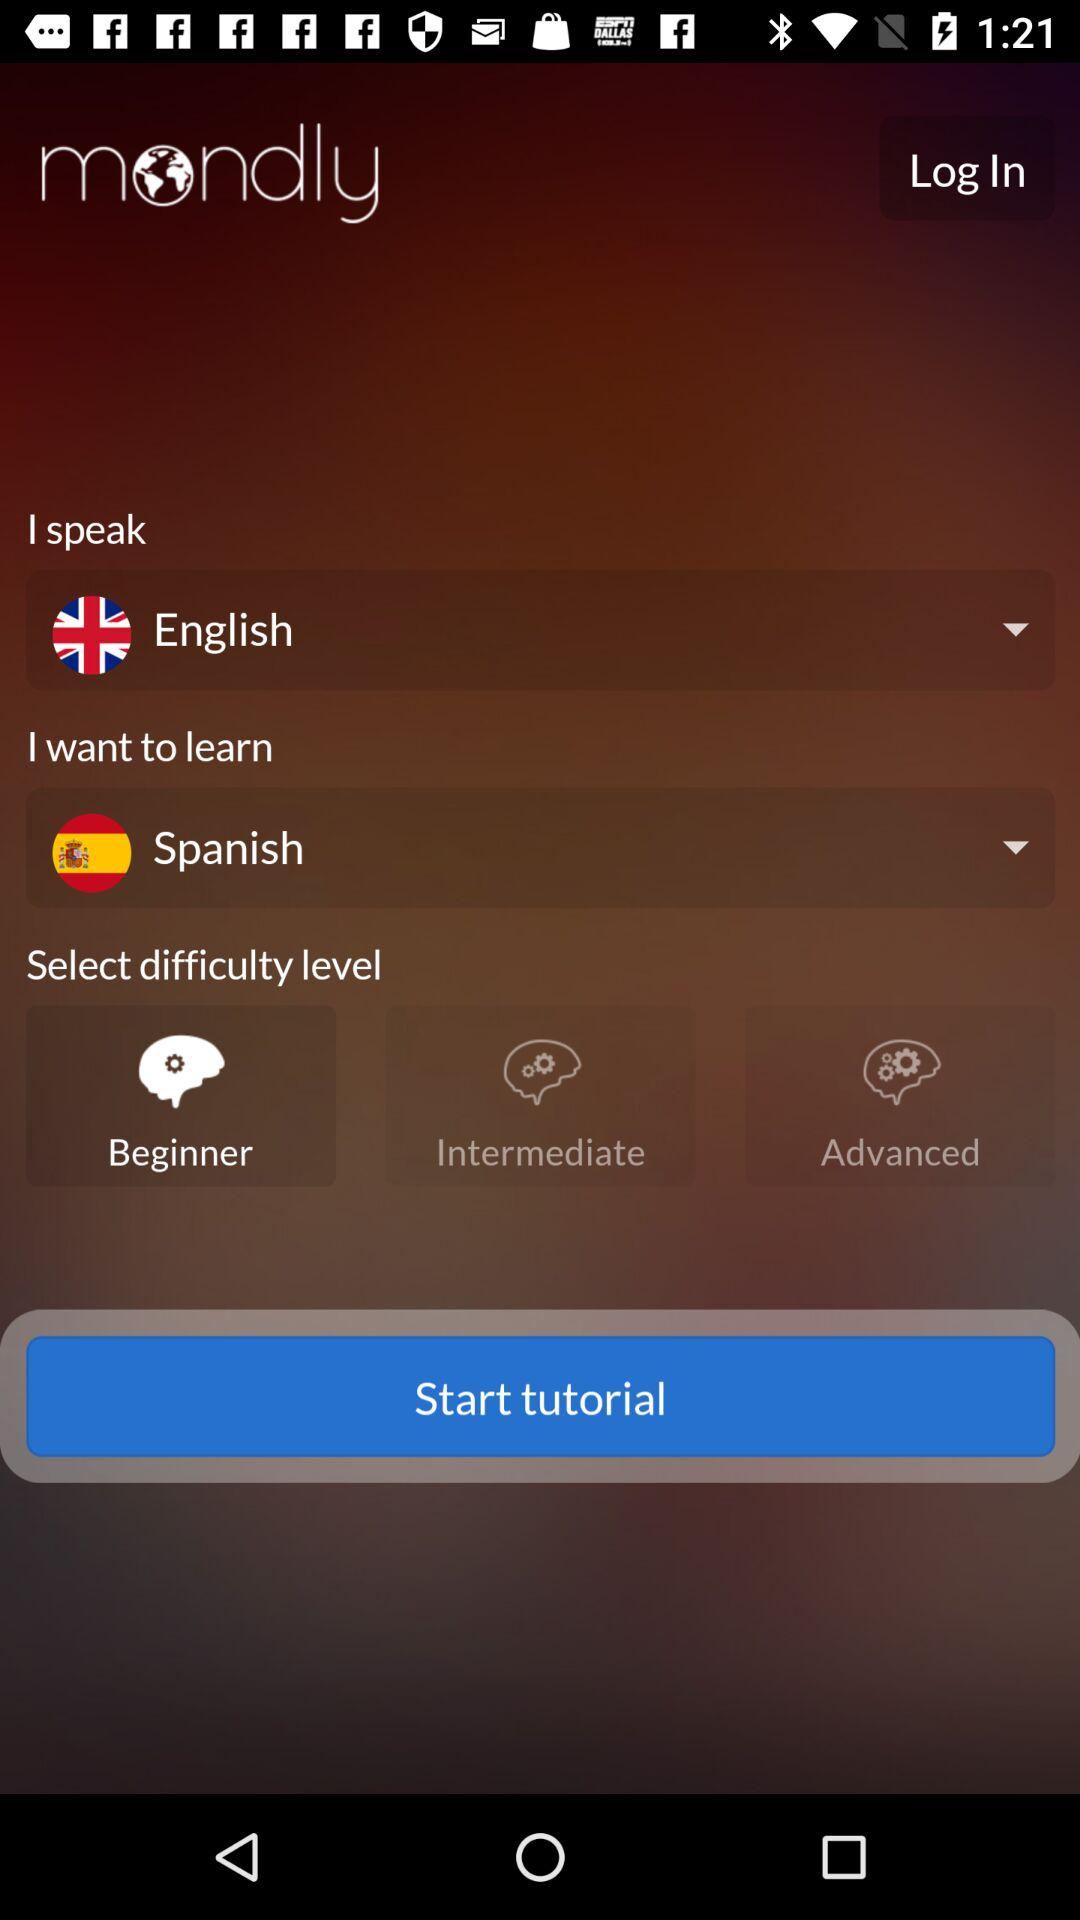How many levels of difficulty are there?
Answer the question using a single word or phrase. 3 